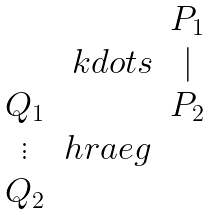<formula> <loc_0><loc_0><loc_500><loc_500>\begin{matrix} & & P _ { 1 } \\ & \ k d o t s & | \\ Q _ { 1 } & & P _ { 2 } \\ \vdots & h r a e g \\ Q _ { 2 } & & \end{matrix}</formula> 